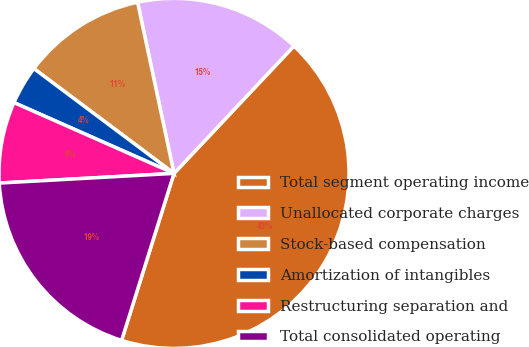Convert chart. <chart><loc_0><loc_0><loc_500><loc_500><pie_chart><fcel>Total segment operating income<fcel>Unallocated corporate charges<fcel>Stock-based compensation<fcel>Amortization of intangibles<fcel>Restructuring separation and<fcel>Total consolidated operating<nl><fcel>42.82%<fcel>15.36%<fcel>11.44%<fcel>3.59%<fcel>7.51%<fcel>19.28%<nl></chart> 